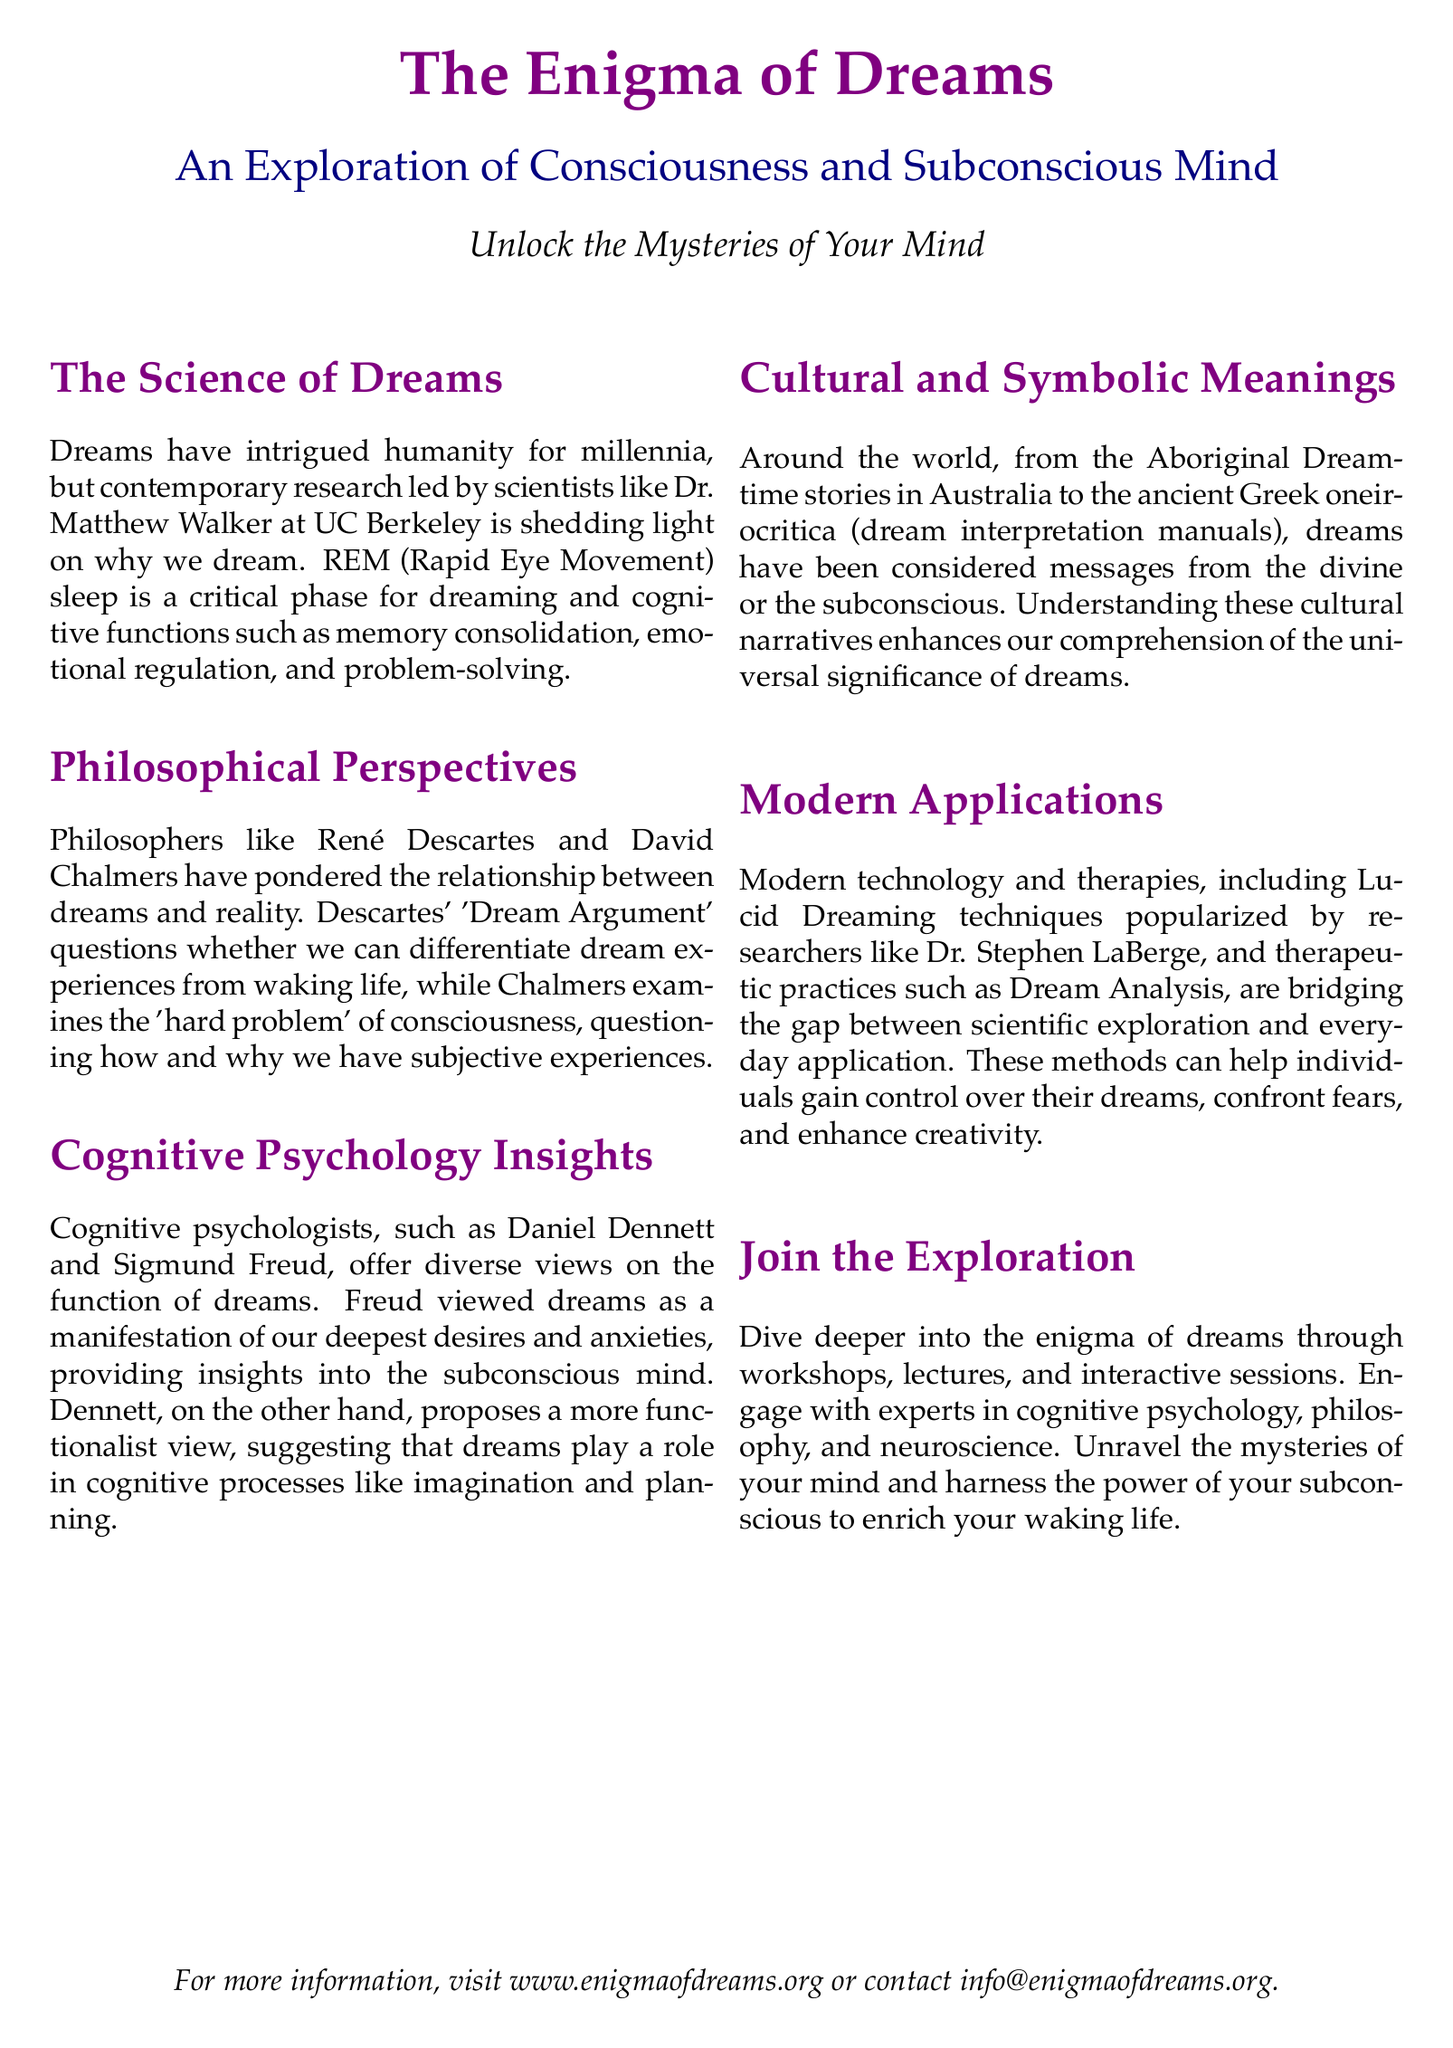What is the main focus of the flyer? The flyer emphasizes the exploration of consciousness and the subconscious mind through the study of dreams.
Answer: Exploration of Consciousness and Subconscious Mind Who is a notable scientist mentioned in the document? The document highlights Dr. Matthew Walker from UC Berkeley as a key figure in contemporary dream research.
Answer: Dr. Matthew Walker What critical phase is essential for dreaming? The flyer cites REM (Rapid Eye Movement) sleep as a crucial phase for dreaming and cognitive functions.
Answer: REM (Rapid Eye Movement) Which philosopher's 'Dream Argument' is discussed? René Descartes' 'Dream Argument' is mentioned as a significant philosophical perspective regarding dreams and reality.
Answer: René Descartes What technique is popularized by Dr. Stephen LaBerge? The flyer references Lucid Dreaming techniques as a modern application related to dream exploration.
Answer: Lucid Dreaming What ancient culture's stories are mentioned regarding dreams? Aboriginal Dreamtime stories from Australia are referenced in connection with cultural meanings of dreams.
Answer: Aboriginal Dreamtime Which psychologist viewed dreams as manifestations of desires and anxieties? Sigmund Freud is identified as the psychologist who interpreted dreams in terms of subconscious desires.
Answer: Sigmund Freud What is a potential benefit of Dream Analysis mentioned in the document? The flyer suggests that Dream Analysis techniques can help individuals confront fears and enhance creativity.
Answer: Confront fears and enhance creativity What is the website for more information? The flyer provides a website for additional details about the exploration of dreams and consciousness.
Answer: www.enigmaofdreams.org 